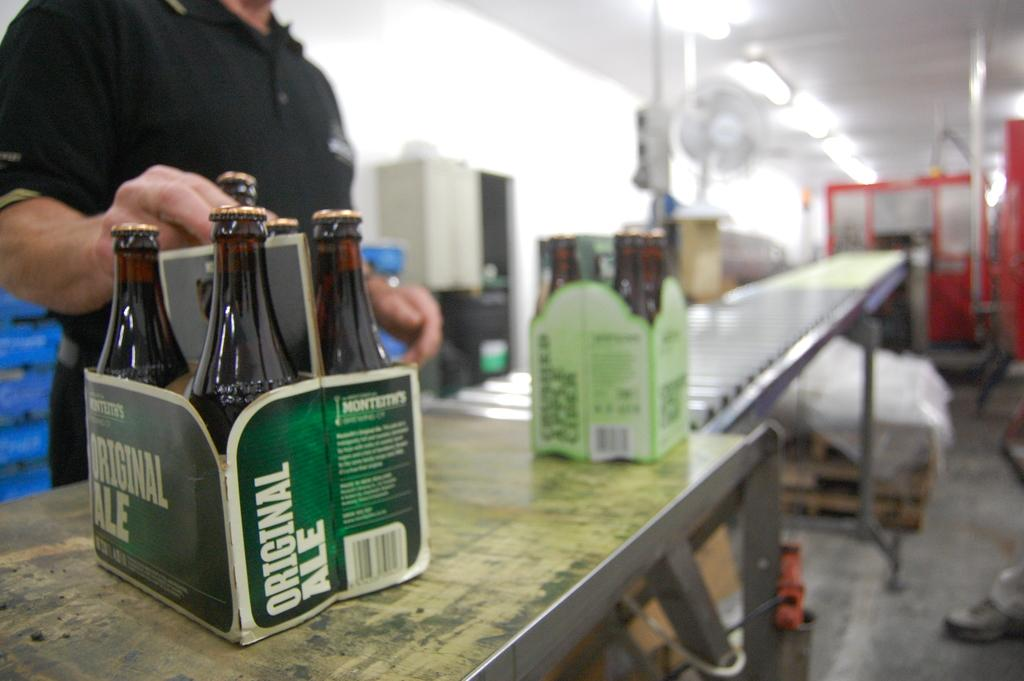<image>
Share a concise interpretation of the image provided. A man in black shirt is grabbing a bottle from a pack of Original Ale. 